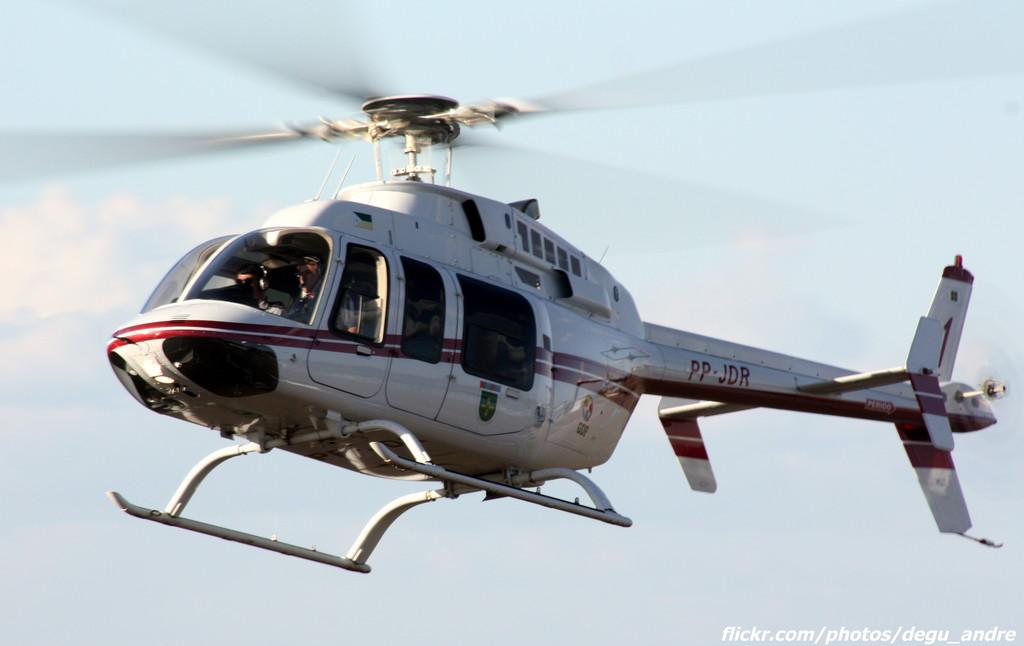What is the helicopter's number?
Give a very brief answer. 1. Which website is listed on the picture?
Your answer should be very brief. Flickr.com/photos/degu_andre. 